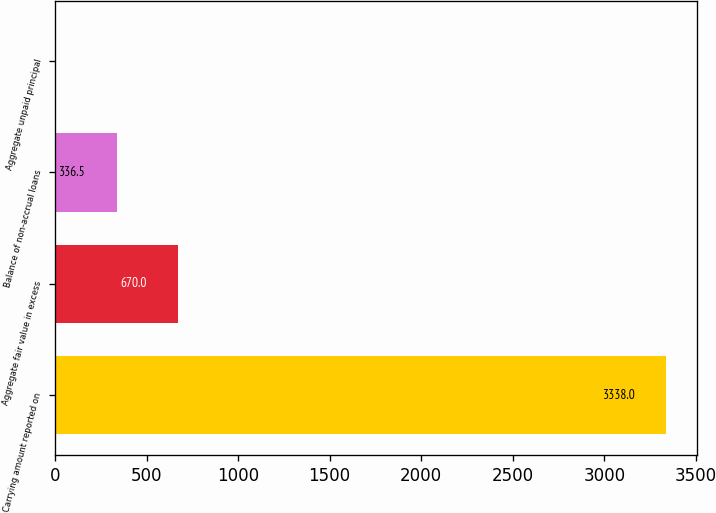Convert chart. <chart><loc_0><loc_0><loc_500><loc_500><bar_chart><fcel>Carrying amount reported on<fcel>Aggregate fair value in excess<fcel>Balance of non-accrual loans<fcel>Aggregate unpaid principal<nl><fcel>3338<fcel>670<fcel>336.5<fcel>3<nl></chart> 